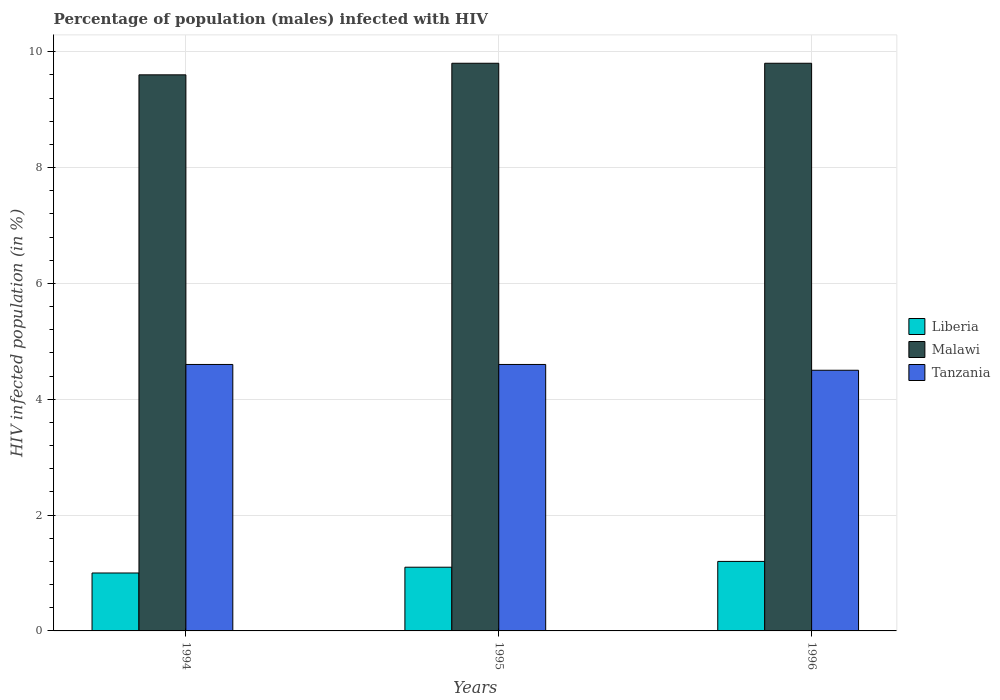How many different coloured bars are there?
Your answer should be compact. 3. How many groups of bars are there?
Provide a short and direct response. 3. Are the number of bars per tick equal to the number of legend labels?
Your response must be concise. Yes. Are the number of bars on each tick of the X-axis equal?
Your response must be concise. Yes. How many bars are there on the 3rd tick from the left?
Provide a short and direct response. 3. Across all years, what is the maximum percentage of HIV infected male population in Malawi?
Your response must be concise. 9.8. In which year was the percentage of HIV infected male population in Malawi minimum?
Provide a succinct answer. 1994. What is the difference between the percentage of HIV infected male population in Tanzania in 1995 and that in 1996?
Give a very brief answer. 0.1. What is the difference between the percentage of HIV infected male population in Liberia in 1994 and the percentage of HIV infected male population in Tanzania in 1995?
Ensure brevity in your answer.  -3.6. What is the average percentage of HIV infected male population in Tanzania per year?
Keep it short and to the point. 4.57. In the year 1996, what is the difference between the percentage of HIV infected male population in Malawi and percentage of HIV infected male population in Liberia?
Offer a very short reply. 8.6. What is the ratio of the percentage of HIV infected male population in Liberia in 1994 to that in 1995?
Make the answer very short. 0.91. Is the difference between the percentage of HIV infected male population in Malawi in 1995 and 1996 greater than the difference between the percentage of HIV infected male population in Liberia in 1995 and 1996?
Provide a short and direct response. Yes. What is the difference between the highest and the second highest percentage of HIV infected male population in Liberia?
Your answer should be very brief. 0.1. What is the difference between the highest and the lowest percentage of HIV infected male population in Malawi?
Provide a short and direct response. 0.2. Is the sum of the percentage of HIV infected male population in Liberia in 1994 and 1995 greater than the maximum percentage of HIV infected male population in Tanzania across all years?
Your answer should be very brief. No. What does the 3rd bar from the left in 1996 represents?
Your response must be concise. Tanzania. What does the 1st bar from the right in 1994 represents?
Offer a terse response. Tanzania. How many bars are there?
Your answer should be compact. 9. What is the difference between two consecutive major ticks on the Y-axis?
Offer a terse response. 2. Does the graph contain any zero values?
Offer a very short reply. No. Does the graph contain grids?
Your answer should be compact. Yes. Where does the legend appear in the graph?
Your response must be concise. Center right. How many legend labels are there?
Your response must be concise. 3. What is the title of the graph?
Provide a short and direct response. Percentage of population (males) infected with HIV. What is the label or title of the Y-axis?
Offer a terse response. HIV infected population (in %). What is the HIV infected population (in %) of Liberia in 1994?
Give a very brief answer. 1. What is the HIV infected population (in %) in Malawi in 1994?
Keep it short and to the point. 9.6. What is the HIV infected population (in %) in Tanzania in 1994?
Keep it short and to the point. 4.6. What is the HIV infected population (in %) in Malawi in 1995?
Your response must be concise. 9.8. What is the HIV infected population (in %) in Tanzania in 1995?
Give a very brief answer. 4.6. Across all years, what is the minimum HIV infected population (in %) of Liberia?
Ensure brevity in your answer.  1. Across all years, what is the minimum HIV infected population (in %) of Malawi?
Offer a terse response. 9.6. Across all years, what is the minimum HIV infected population (in %) in Tanzania?
Ensure brevity in your answer.  4.5. What is the total HIV infected population (in %) of Liberia in the graph?
Give a very brief answer. 3.3. What is the total HIV infected population (in %) of Malawi in the graph?
Your answer should be very brief. 29.2. What is the total HIV infected population (in %) in Tanzania in the graph?
Offer a terse response. 13.7. What is the difference between the HIV infected population (in %) of Malawi in 1994 and that in 1996?
Provide a short and direct response. -0.2. What is the difference between the HIV infected population (in %) of Liberia in 1995 and that in 1996?
Ensure brevity in your answer.  -0.1. What is the difference between the HIV infected population (in %) of Malawi in 1995 and that in 1996?
Your answer should be very brief. 0. What is the difference between the HIV infected population (in %) in Malawi in 1994 and the HIV infected population (in %) in Tanzania in 1995?
Your answer should be very brief. 5. What is the difference between the HIV infected population (in %) of Liberia in 1994 and the HIV infected population (in %) of Malawi in 1996?
Give a very brief answer. -8.8. What is the difference between the HIV infected population (in %) of Malawi in 1994 and the HIV infected population (in %) of Tanzania in 1996?
Your response must be concise. 5.1. What is the difference between the HIV infected population (in %) of Liberia in 1995 and the HIV infected population (in %) of Malawi in 1996?
Provide a succinct answer. -8.7. What is the difference between the HIV infected population (in %) in Liberia in 1995 and the HIV infected population (in %) in Tanzania in 1996?
Your answer should be very brief. -3.4. What is the difference between the HIV infected population (in %) of Malawi in 1995 and the HIV infected population (in %) of Tanzania in 1996?
Provide a succinct answer. 5.3. What is the average HIV infected population (in %) in Malawi per year?
Make the answer very short. 9.73. What is the average HIV infected population (in %) of Tanzania per year?
Your response must be concise. 4.57. In the year 1995, what is the difference between the HIV infected population (in %) of Liberia and HIV infected population (in %) of Tanzania?
Keep it short and to the point. -3.5. In the year 1995, what is the difference between the HIV infected population (in %) in Malawi and HIV infected population (in %) in Tanzania?
Your answer should be very brief. 5.2. In the year 1996, what is the difference between the HIV infected population (in %) in Liberia and HIV infected population (in %) in Tanzania?
Offer a very short reply. -3.3. In the year 1996, what is the difference between the HIV infected population (in %) in Malawi and HIV infected population (in %) in Tanzania?
Provide a succinct answer. 5.3. What is the ratio of the HIV infected population (in %) in Liberia in 1994 to that in 1995?
Keep it short and to the point. 0.91. What is the ratio of the HIV infected population (in %) of Malawi in 1994 to that in 1995?
Ensure brevity in your answer.  0.98. What is the ratio of the HIV infected population (in %) in Malawi in 1994 to that in 1996?
Ensure brevity in your answer.  0.98. What is the ratio of the HIV infected population (in %) of Tanzania in 1994 to that in 1996?
Provide a succinct answer. 1.02. What is the ratio of the HIV infected population (in %) in Malawi in 1995 to that in 1996?
Your answer should be very brief. 1. What is the ratio of the HIV infected population (in %) of Tanzania in 1995 to that in 1996?
Ensure brevity in your answer.  1.02. What is the difference between the highest and the second highest HIV infected population (in %) in Liberia?
Offer a terse response. 0.1. What is the difference between the highest and the second highest HIV infected population (in %) of Malawi?
Your response must be concise. 0. What is the difference between the highest and the lowest HIV infected population (in %) in Tanzania?
Provide a succinct answer. 0.1. 